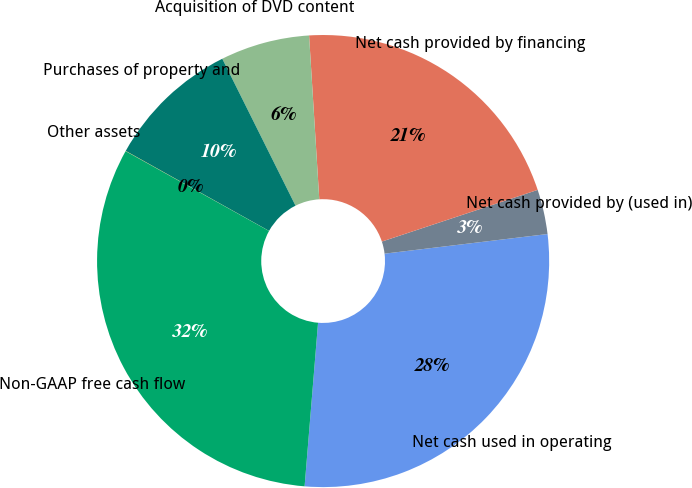Convert chart. <chart><loc_0><loc_0><loc_500><loc_500><pie_chart><fcel>Net cash used in operating<fcel>Net cash provided by (used in)<fcel>Net cash provided by financing<fcel>Acquisition of DVD content<fcel>Purchases of property and<fcel>Other assets<fcel>Non-GAAP free cash flow<nl><fcel>28.21%<fcel>3.19%<fcel>20.89%<fcel>6.37%<fcel>9.54%<fcel>0.02%<fcel>31.77%<nl></chart> 